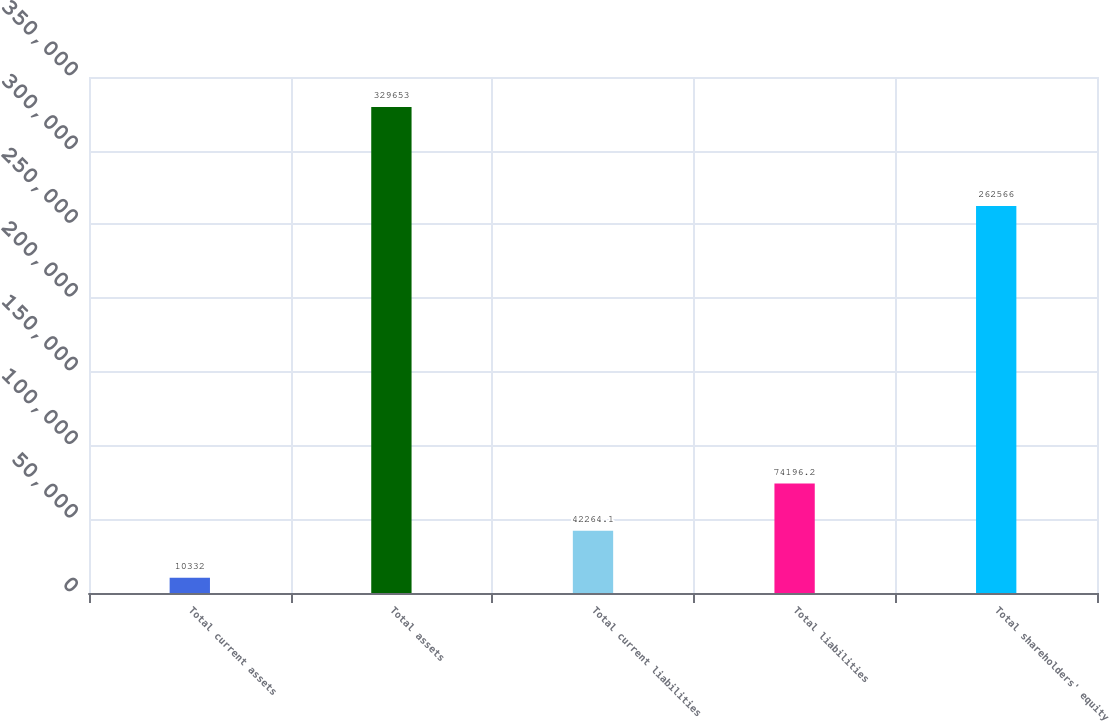<chart> <loc_0><loc_0><loc_500><loc_500><bar_chart><fcel>Total current assets<fcel>Total assets<fcel>Total current liabilities<fcel>Total liabilities<fcel>Total shareholders' equity<nl><fcel>10332<fcel>329653<fcel>42264.1<fcel>74196.2<fcel>262566<nl></chart> 